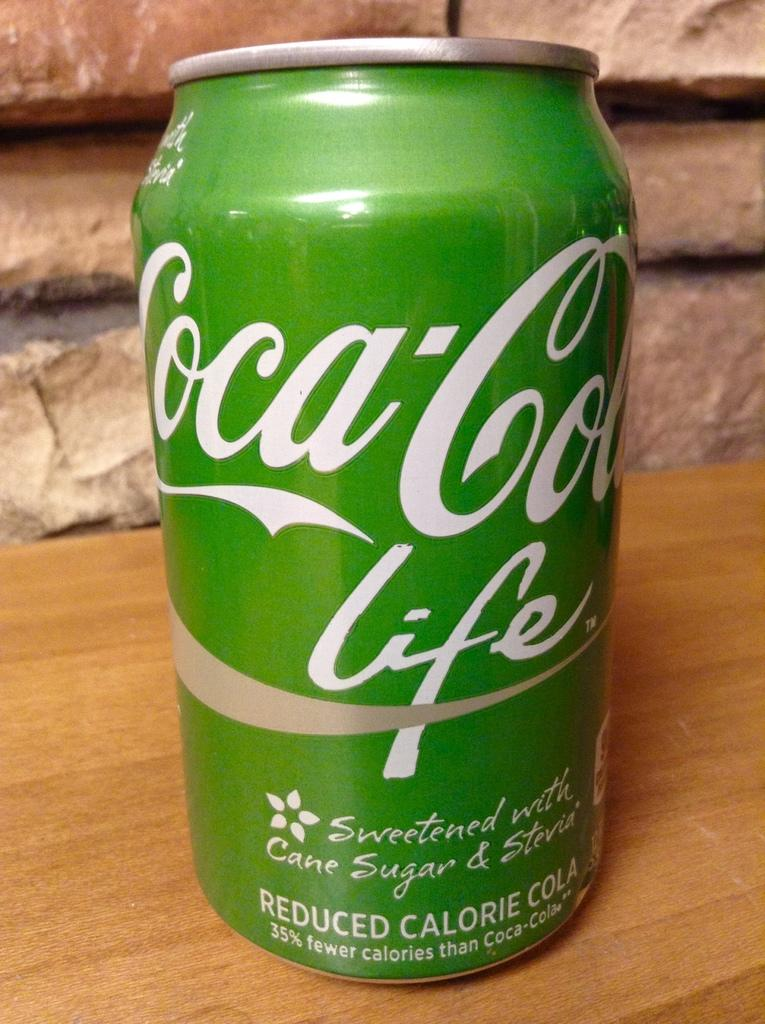<image>
Provide a brief description of the given image. A green can of Coca-cola life says it has reduced calories. 